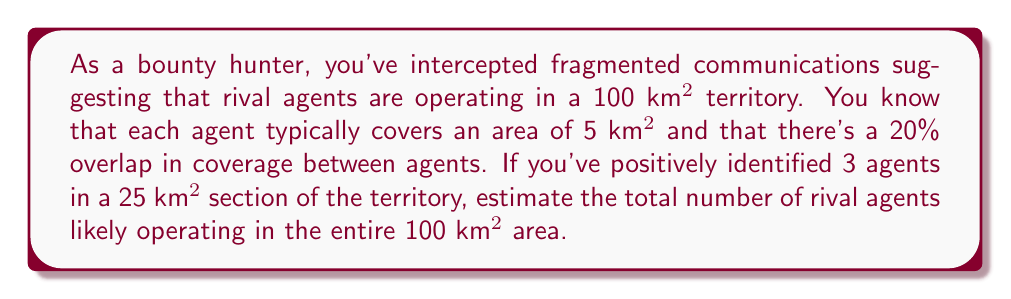Help me with this question. Let's approach this problem step-by-step:

1) First, let's calculate the effective area covered by each agent:
   Effective area = Area per agent - Overlap
   $$ 5 \text{ km}^2 - (5 \text{ km}^2 \times 0.20) = 4 \text{ km}^2 $$

2) Now, let's determine the density of agents in the 25 km² section:
   $$ \text{Density} = \frac{3 \text{ agents}}{25 \text{ km}^2} = 0.12 \text{ agents/km}^2 $$

3) Assuming this density is consistent across the territory, we can estimate the total number of agents in 100 km²:
   $$ \text{Estimated agents} = 0.12 \text{ agents/km}^2 \times 100 \text{ km}^2 = 12 \text{ agents} $$

4) However, we need to account for the overlap. The total area effectively covered by these 12 agents would be:
   $$ 12 \text{ agents} \times 4 \text{ km}^2/\text{agent} = 48 \text{ km}^2 $$

5) This leaves 52 km² uncovered. To cover this area, we need:
   $$ \frac{52 \text{ km}^2}{4 \text{ km}^2/\text{agent}} = 13 \text{ additional agents} $$

6) Therefore, the total estimated number of agents is:
   $$ 12 + 13 = 25 \text{ agents} $$

This estimate assumes uniform distribution and consistent behavior across the territory, which may not always be the case in real-world scenarios.
Answer: Approximately 25 rival agents 